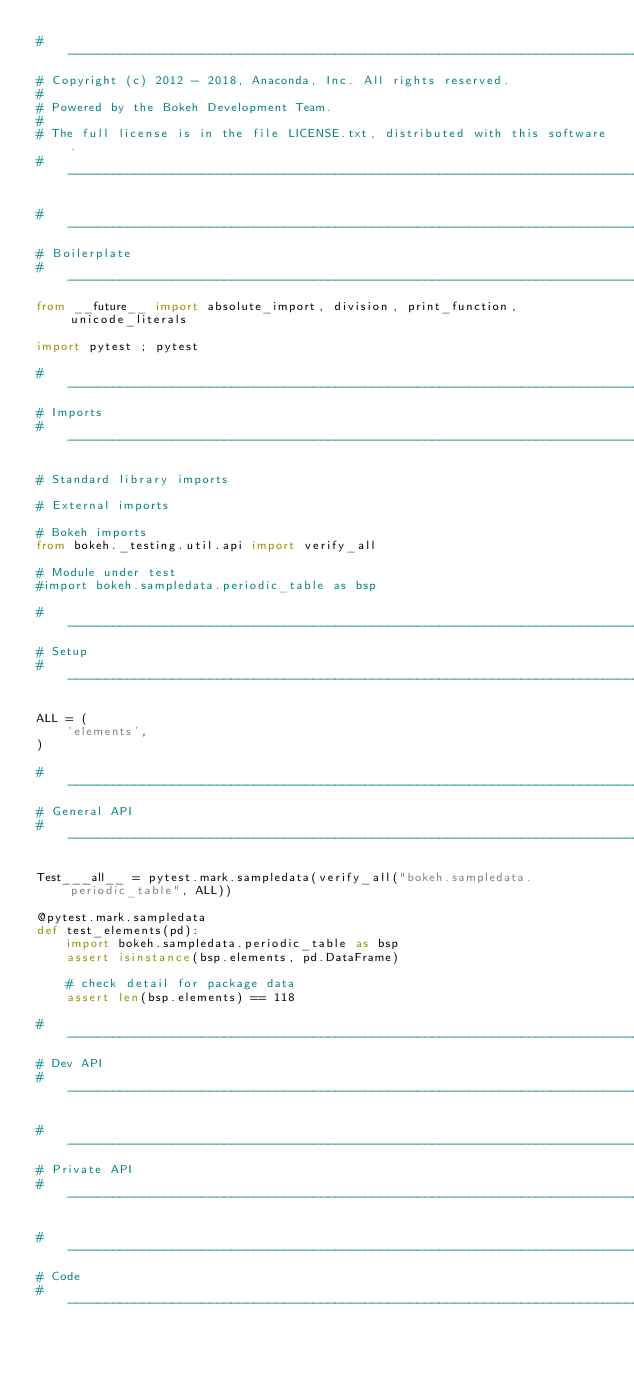<code> <loc_0><loc_0><loc_500><loc_500><_Python_>#-----------------------------------------------------------------------------
# Copyright (c) 2012 - 2018, Anaconda, Inc. All rights reserved.
#
# Powered by the Bokeh Development Team.
#
# The full license is in the file LICENSE.txt, distributed with this software.
#-----------------------------------------------------------------------------

#-----------------------------------------------------------------------------
# Boilerplate
#-----------------------------------------------------------------------------
from __future__ import absolute_import, division, print_function, unicode_literals

import pytest ; pytest

#-----------------------------------------------------------------------------
# Imports
#-----------------------------------------------------------------------------

# Standard library imports

# External imports

# Bokeh imports
from bokeh._testing.util.api import verify_all

# Module under test
#import bokeh.sampledata.periodic_table as bsp

#-----------------------------------------------------------------------------
# Setup
#-----------------------------------------------------------------------------

ALL = (
    'elements',
)

#-----------------------------------------------------------------------------
# General API
#-----------------------------------------------------------------------------

Test___all__ = pytest.mark.sampledata(verify_all("bokeh.sampledata.periodic_table", ALL))

@pytest.mark.sampledata
def test_elements(pd):
    import bokeh.sampledata.periodic_table as bsp
    assert isinstance(bsp.elements, pd.DataFrame)

    # check detail for package data
    assert len(bsp.elements) == 118

#-----------------------------------------------------------------------------
# Dev API
#-----------------------------------------------------------------------------

#-----------------------------------------------------------------------------
# Private API
#-----------------------------------------------------------------------------

#-----------------------------------------------------------------------------
# Code
#-----------------------------------------------------------------------------
</code> 